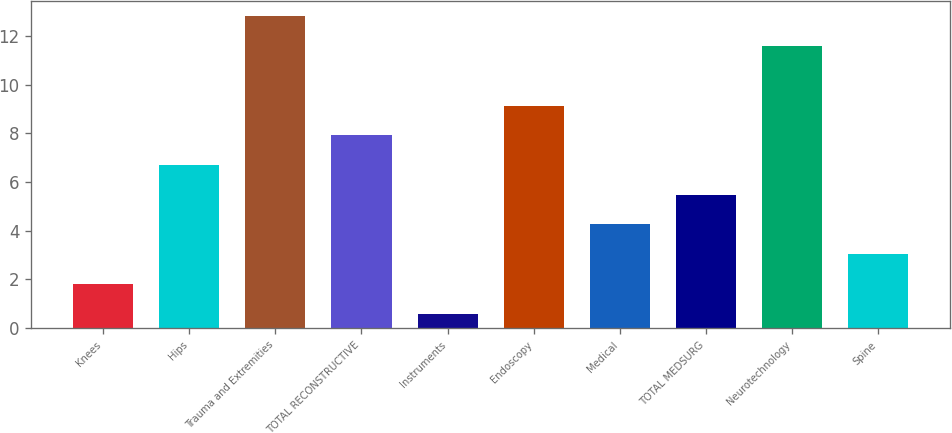Convert chart to OTSL. <chart><loc_0><loc_0><loc_500><loc_500><bar_chart><fcel>Knees<fcel>Hips<fcel>Trauma and Extremities<fcel>TOTAL RECONSTRUCTIVE<fcel>Instruments<fcel>Endoscopy<fcel>Medical<fcel>TOTAL MEDSURG<fcel>Neurotechnology<fcel>Spine<nl><fcel>1.82<fcel>6.7<fcel>12.8<fcel>7.92<fcel>0.6<fcel>9.14<fcel>4.26<fcel>5.48<fcel>11.58<fcel>3.04<nl></chart> 